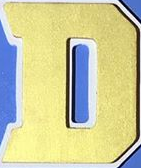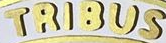Read the text content from these images in order, separated by a semicolon. D; TRIBUS 